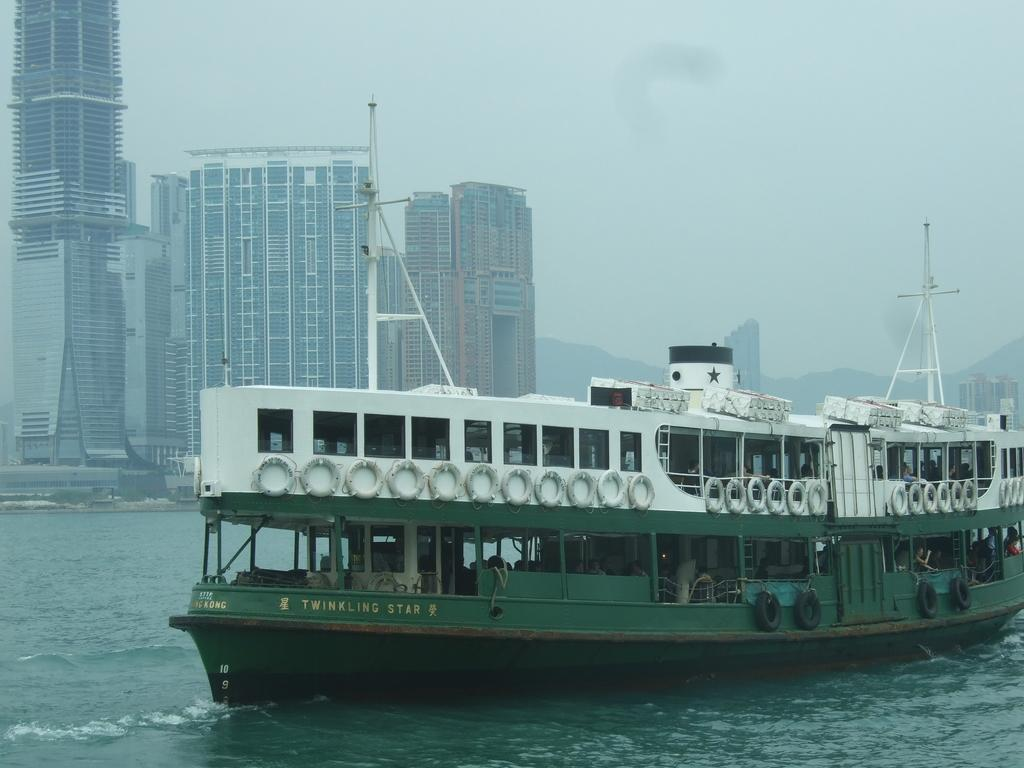What is the main subject of the image? The main subject of the image is a boat. Where is the boat located? The boat is on the water. What can be seen in the background of the image? There are skyscrapers, hills, and the sky visible in the background of the image. What type of winter drink is being prepared on the boat in the image? There is no indication of any cooking or drinks in the image; it only features a boat on the water with a background of skyscrapers, hills, and the sky. 